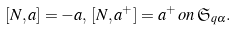<formula> <loc_0><loc_0><loc_500><loc_500>[ N , a ] = - a , \, [ N , a ^ { + } ] = a ^ { + } \, o n \, \mathfrak { S } _ { q \alpha } .</formula> 